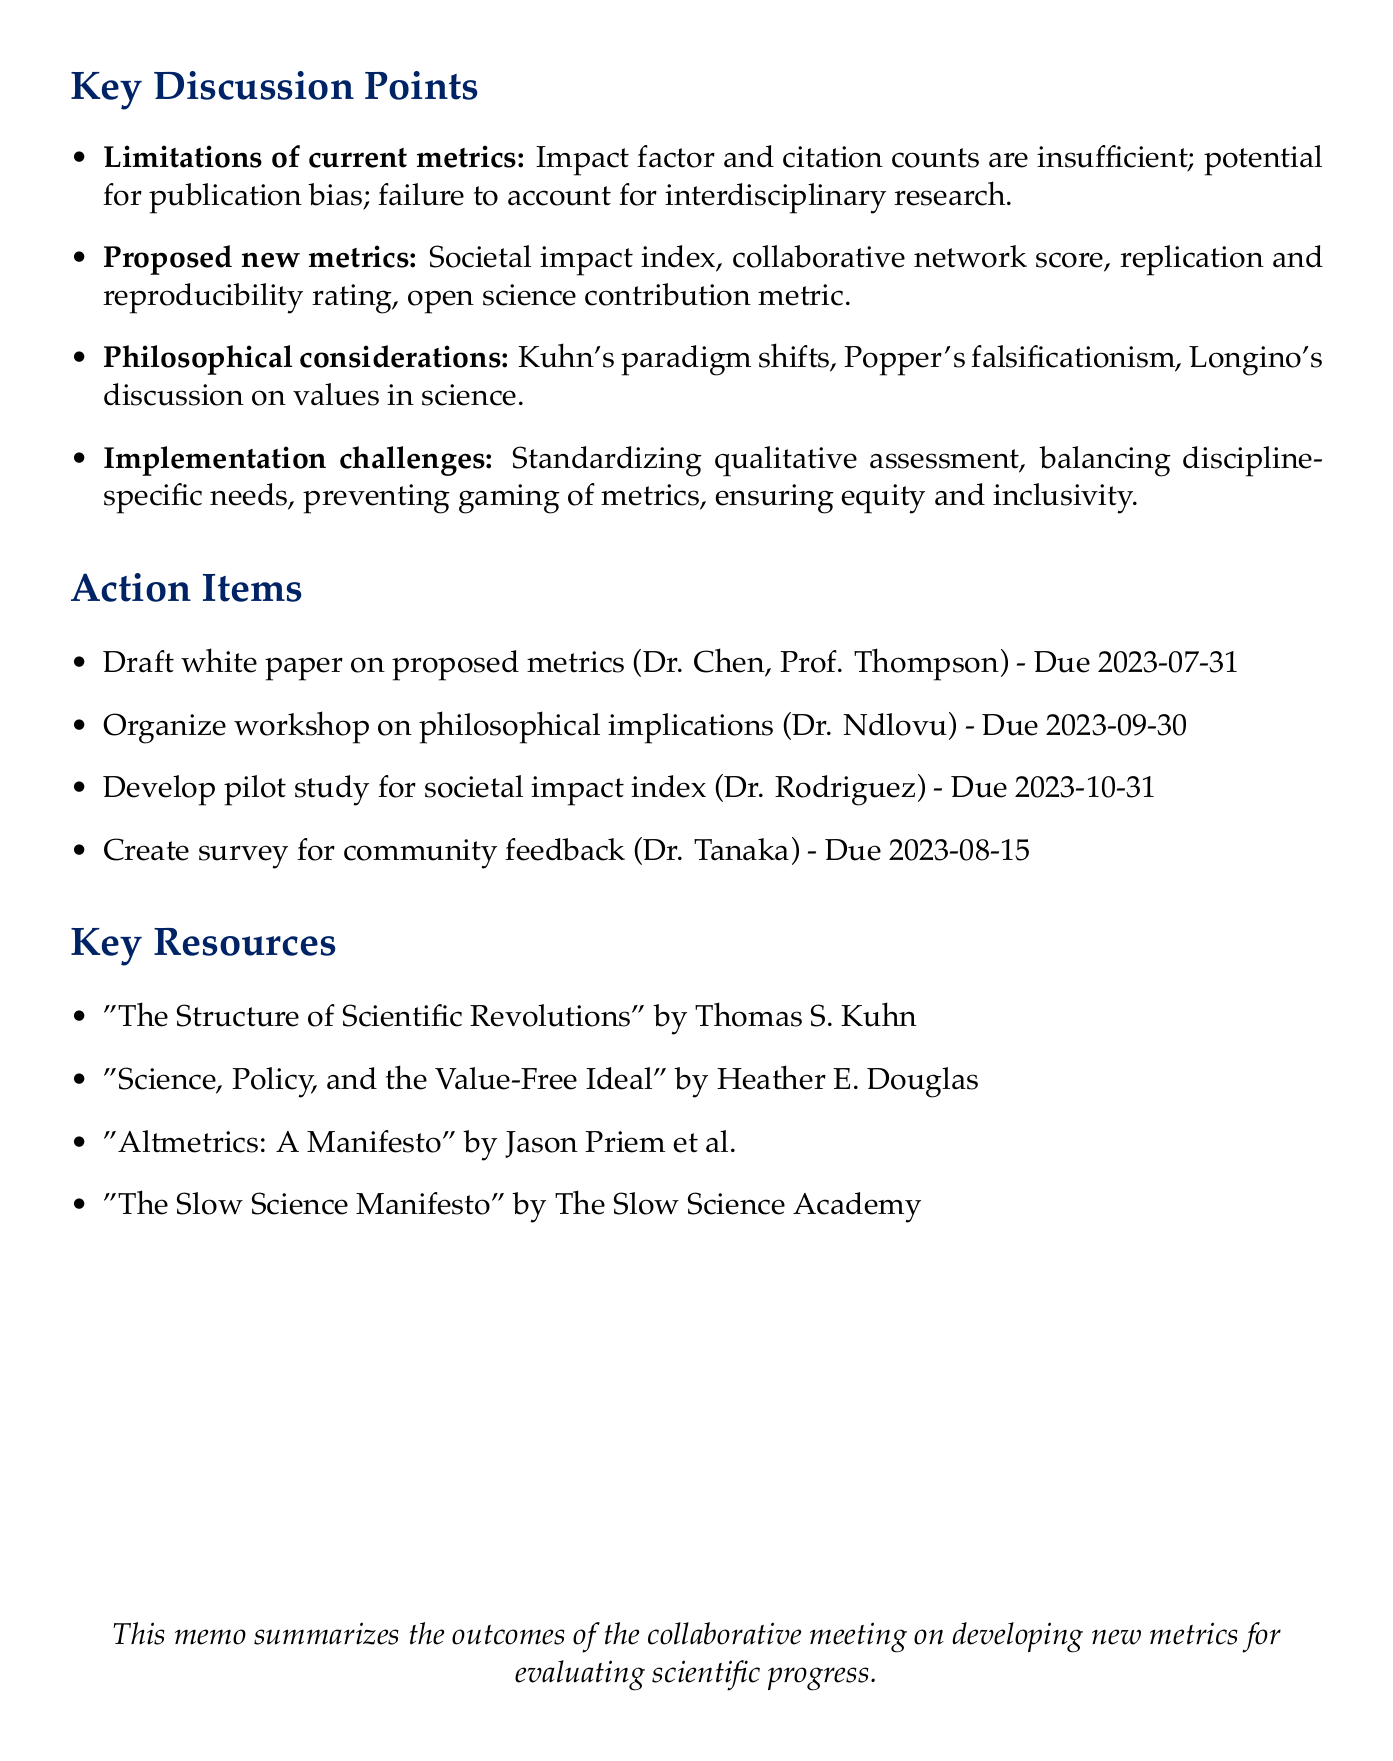What date was the meeting held? The date of the meeting is explicitly stated in the document as May 15, 2023.
Answer: May 15, 2023 Who are the participants from Stanford University? The document lists Dr. Sarah Chen as the participant from Stanford University.
Answer: Dr. Sarah Chen What is one limitation of current metrics mentioned? The document notes that impact factor and citation counts don't capture the full spectrum of scientific value as a limitation.
Answer: Don't capture full spectrum of scientific value What metric is proposed to evaluate interdisciplinary collaborations? The proposed metric for evaluating interdisciplinary collaborations is the collaborative network score.
Answer: Collaborative network score Who is assigned to develop the pilot study for the societal impact index? Dr. Elena Rodriguez is assigned the task of developing the pilot study for the societal impact index.
Answer: Dr. Elena Rodriguez Which philosophical aspect does Helen Longino discuss in relation to scientific progress? The document refers to the role of values in science as discussed by Helen Longino regarding scientific progress.
Answer: Role of values in science What is the deadline for creating a survey for scientific community feedback? The document specifies that the deadline for creating the survey for community feedback is August 15, 2023.
Answer: August 15, 2023 What is one challenge in the implementation of new metrics mentioned? The document indicates that standardizing methods for qualitative assessment is a challenge in implementation.
Answer: Standardizing methods for qualitative assessment 